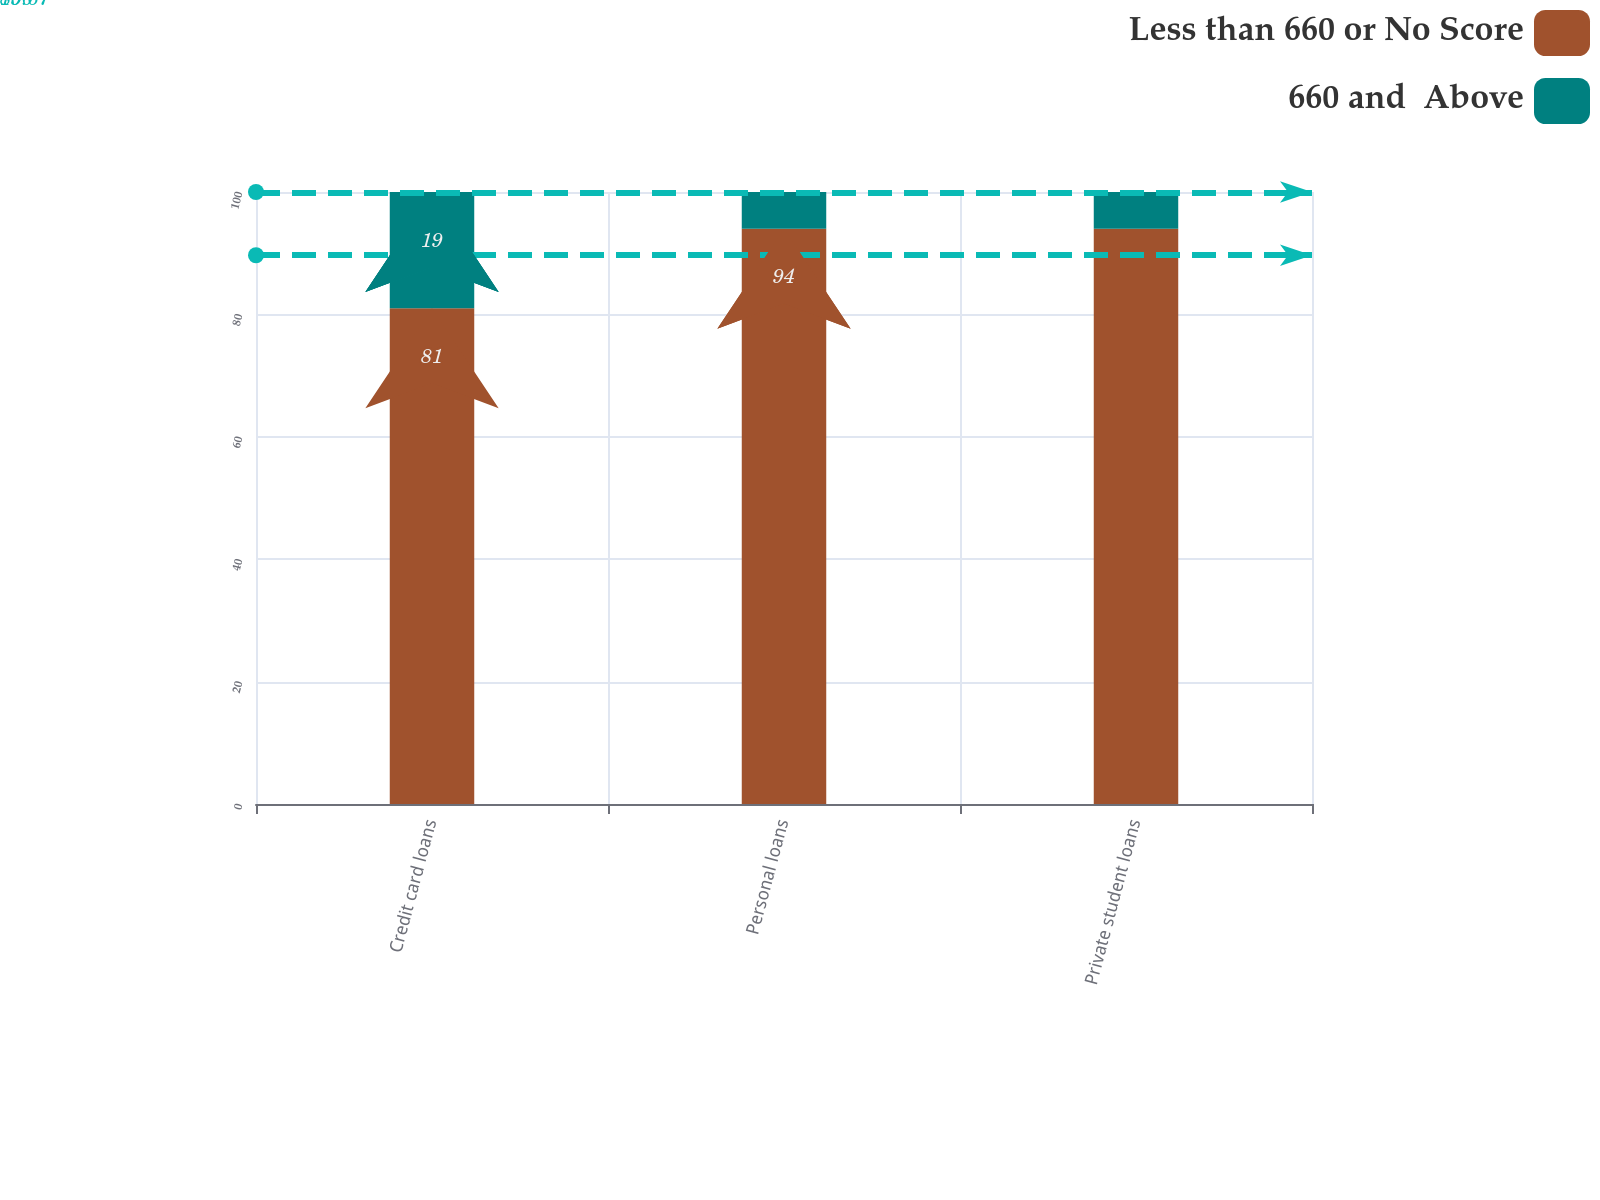Convert chart to OTSL. <chart><loc_0><loc_0><loc_500><loc_500><stacked_bar_chart><ecel><fcel>Credit card loans<fcel>Personal loans<fcel>Private student loans<nl><fcel>Less than 660 or No Score<fcel>81<fcel>94<fcel>94<nl><fcel>660 and  Above<fcel>19<fcel>6<fcel>6<nl></chart> 